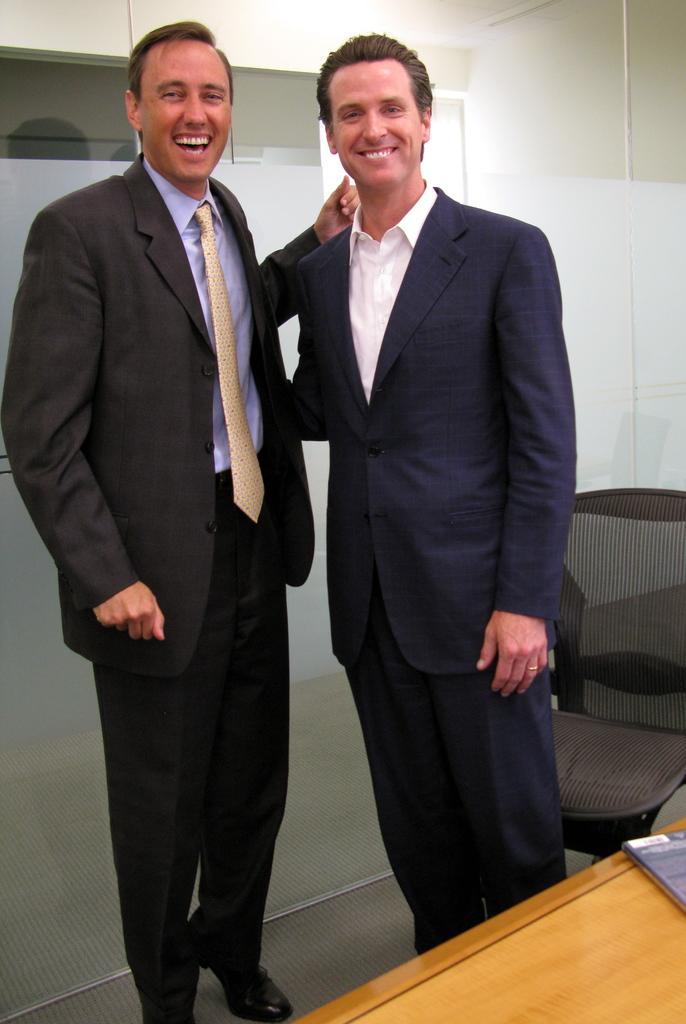Could you give a brief overview of what you see in this image? In the center of the image there are two people wearing suits. At the bottom of the image there is table. In the background of the image there is glass wall. To the right side of the image there is a chair. 